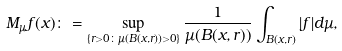Convert formula to latex. <formula><loc_0><loc_0><loc_500><loc_500>M _ { \mu } f ( x ) \colon = \sup _ { \{ r > 0 \colon \mu ( B ( x , r ) ) > 0 \} } \frac { 1 } { \mu ( B ( x , r ) ) } \int _ { B ( x , r ) } | f | d \mu ,</formula> 